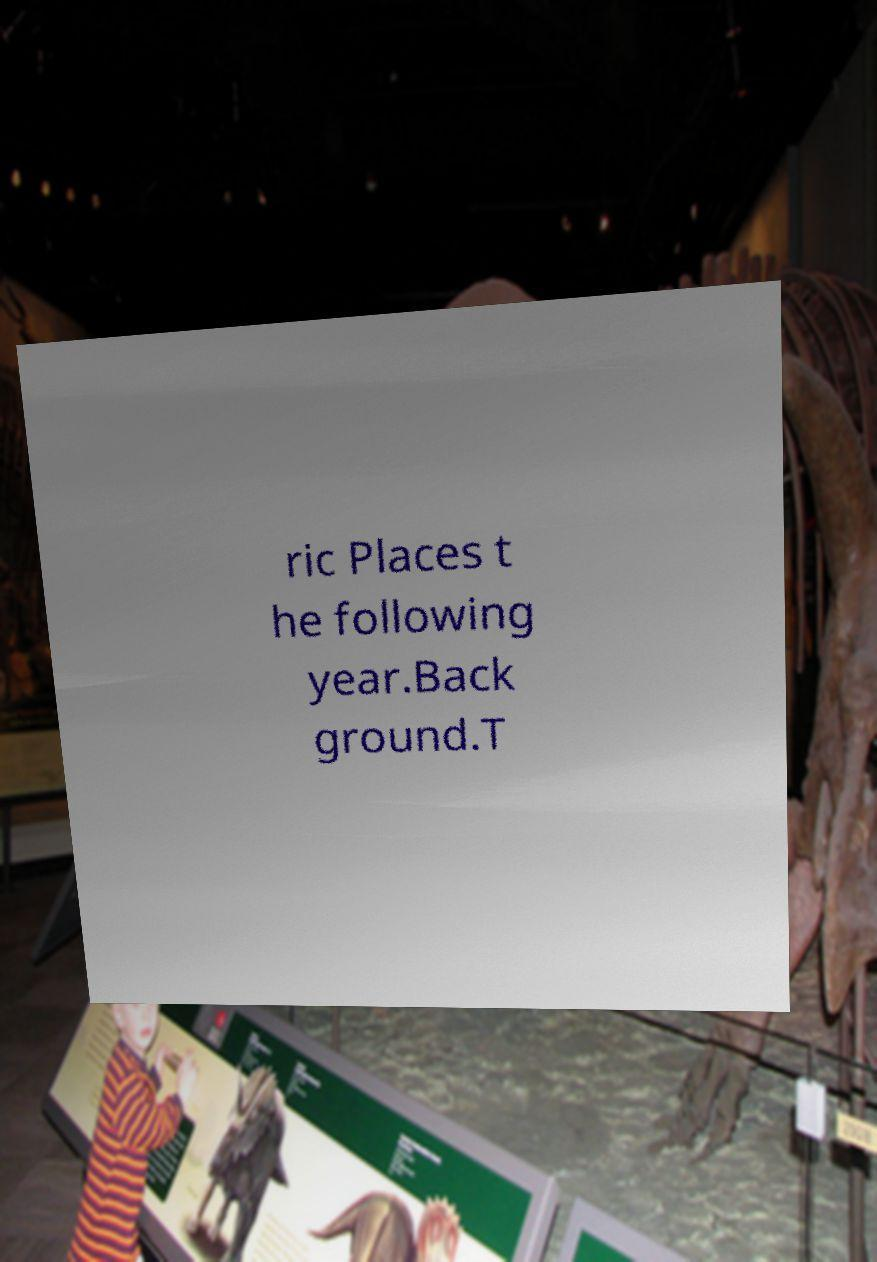For documentation purposes, I need the text within this image transcribed. Could you provide that? ric Places t he following year.Back ground.T 